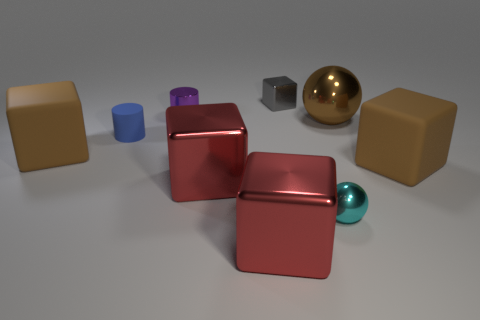What number of cubes are the same material as the small purple cylinder?
Provide a short and direct response. 3. What number of balls are either large metal objects or small cyan objects?
Make the answer very short. 2. There is a brown matte object that is right of the shiny cube that is behind the brown rubber cube that is to the left of the tiny gray cube; what size is it?
Offer a very short reply. Large. The tiny thing that is both on the left side of the gray thing and on the right side of the small blue cylinder is what color?
Offer a terse response. Purple. Do the metallic cylinder and the cylinder on the left side of the small purple metallic cylinder have the same size?
Your response must be concise. Yes. There is a metallic object that is the same shape as the small blue matte object; what color is it?
Keep it short and to the point. Purple. Does the purple thing have the same size as the blue rubber cylinder?
Provide a short and direct response. Yes. How many other things are there of the same size as the brown metal sphere?
Provide a succinct answer. 4. What number of objects are small metallic objects in front of the tiny blue rubber cylinder or big metallic objects behind the cyan metal thing?
Provide a succinct answer. 3. What shape is the gray metallic object that is the same size as the blue matte cylinder?
Your answer should be compact. Cube. 